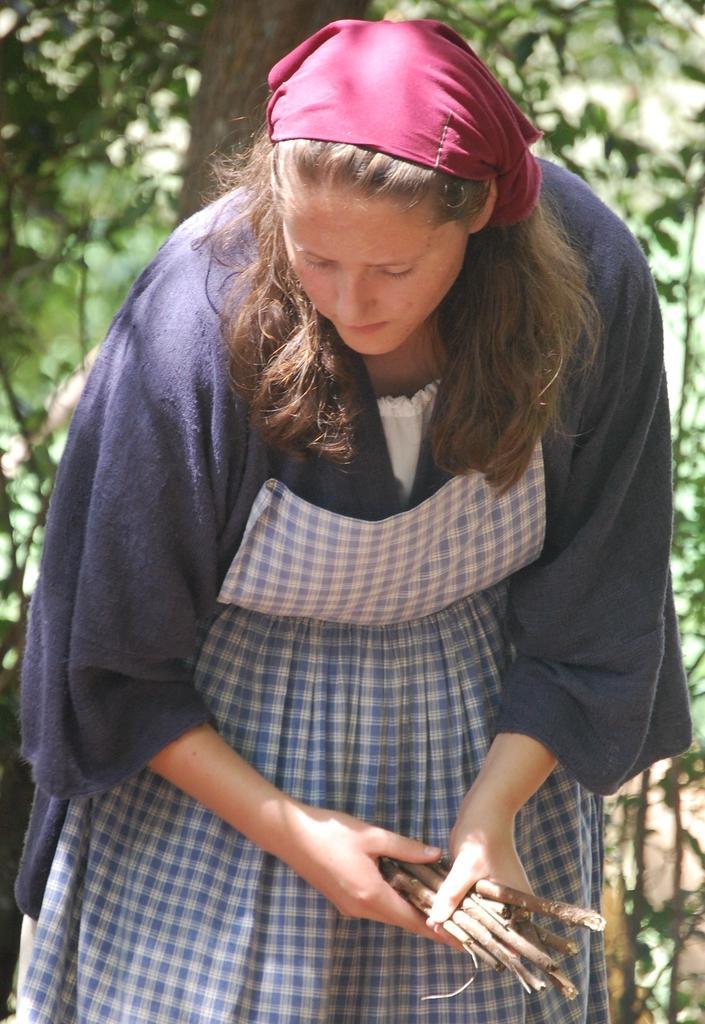Describe this image in one or two sentences. In this image we can see a woman holding the twigs. In the background we can see the trees. 